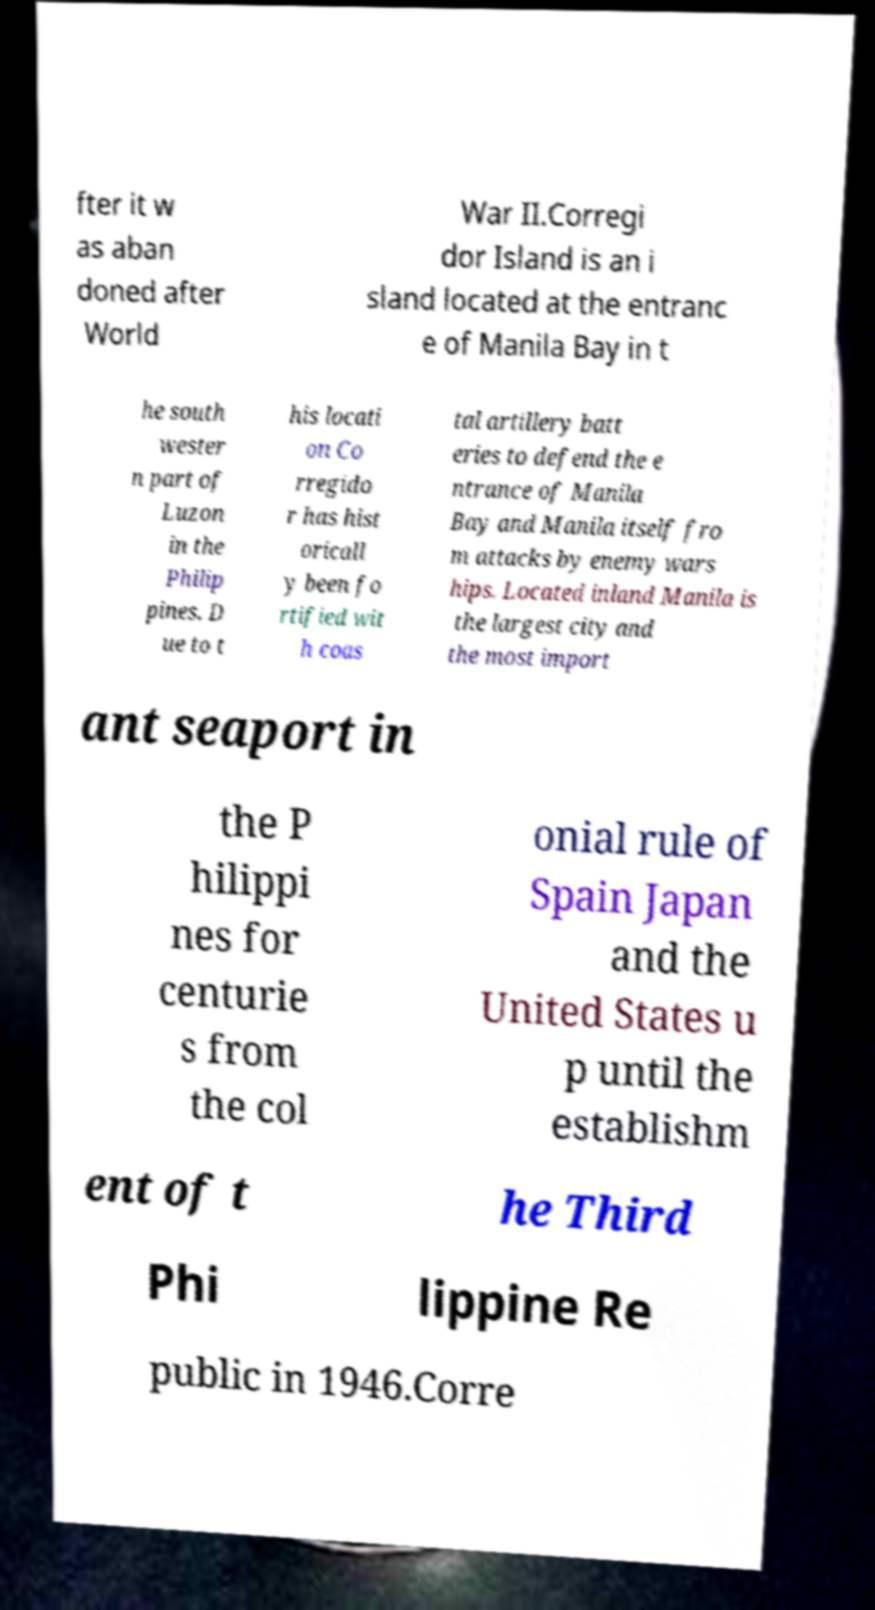For documentation purposes, I need the text within this image transcribed. Could you provide that? fter it w as aban doned after World War II.Corregi dor Island is an i sland located at the entranc e of Manila Bay in t he south wester n part of Luzon in the Philip pines. D ue to t his locati on Co rregido r has hist oricall y been fo rtified wit h coas tal artillery batt eries to defend the e ntrance of Manila Bay and Manila itself fro m attacks by enemy wars hips. Located inland Manila is the largest city and the most import ant seaport in the P hilippi nes for centurie s from the col onial rule of Spain Japan and the United States u p until the establishm ent of t he Third Phi lippine Re public in 1946.Corre 